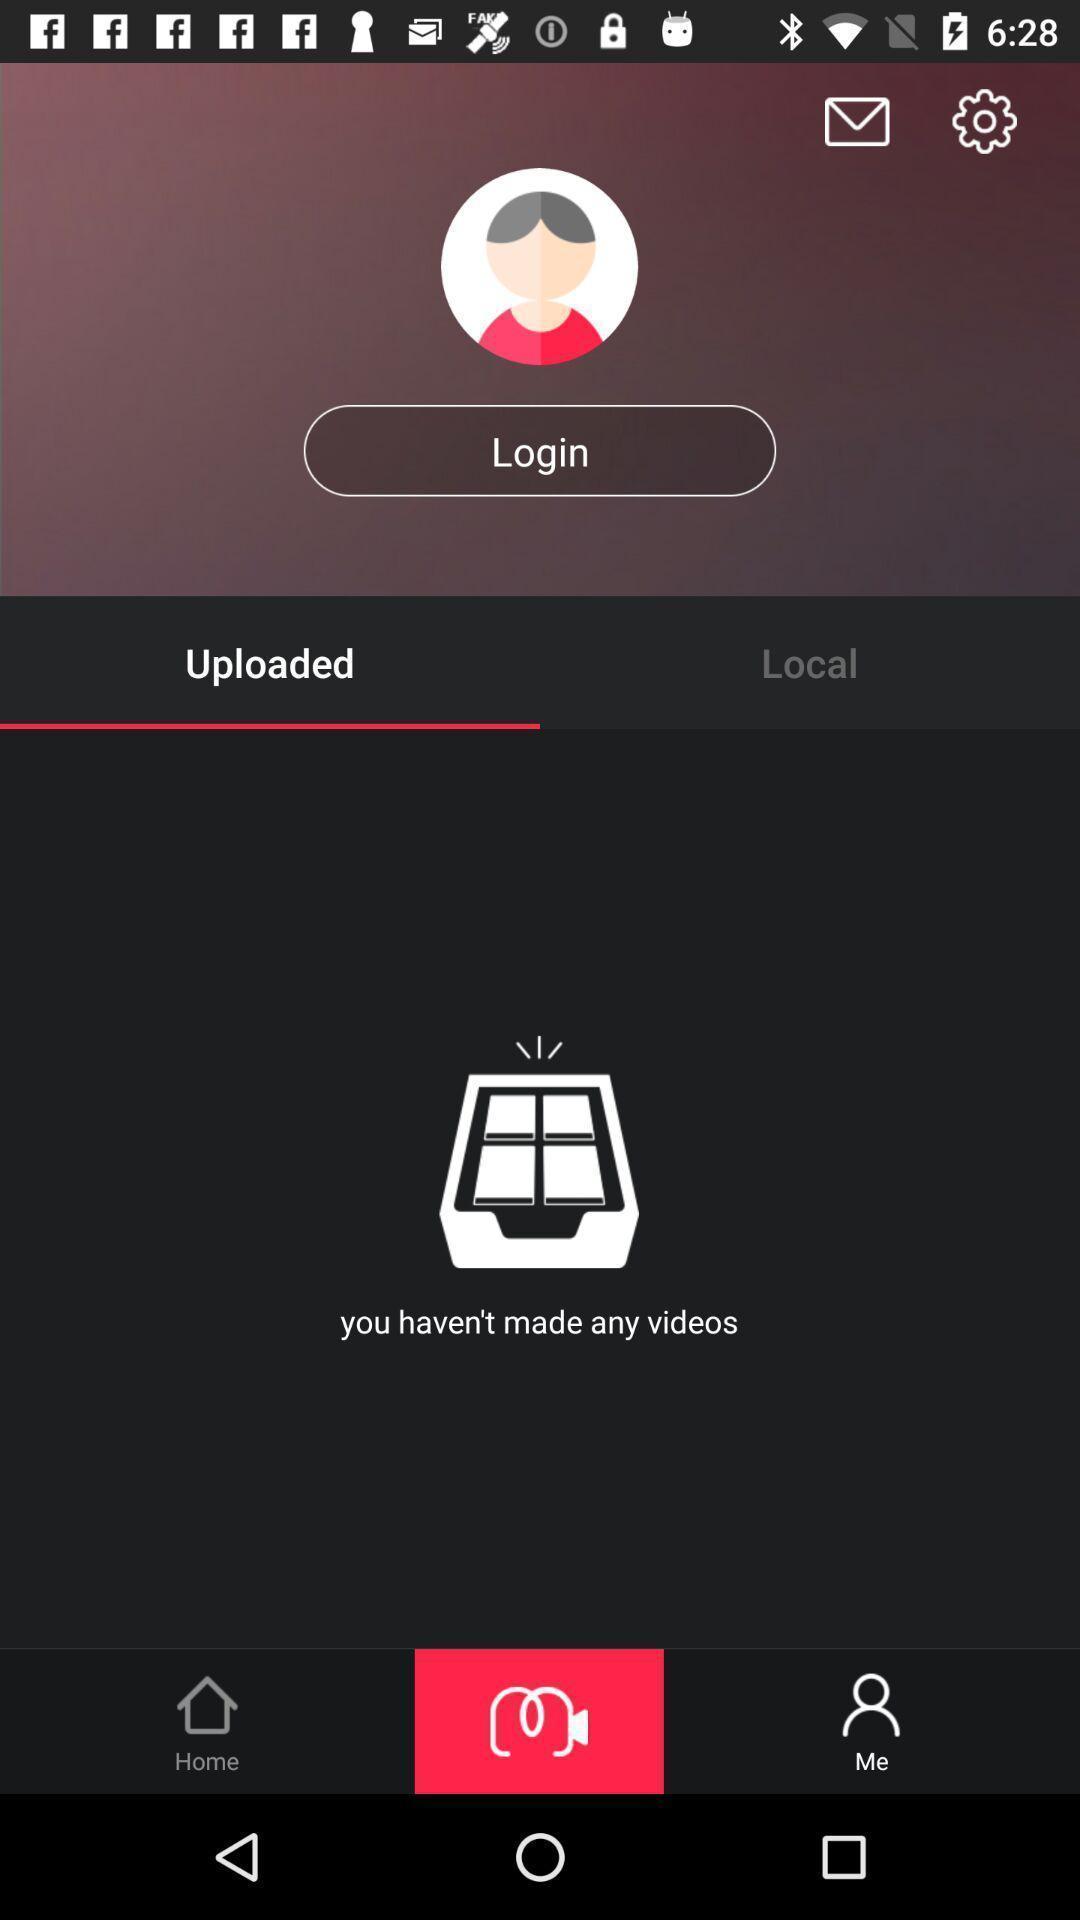What is the overall content of this screenshot? Screen displaying multiple options in videos page. 